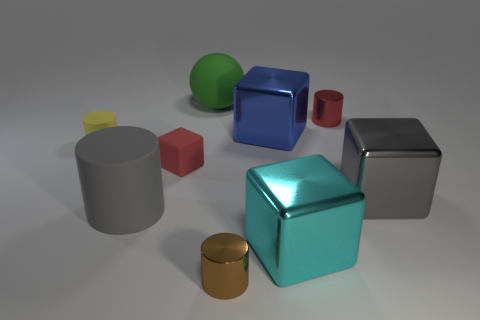Add 1 big cyan matte cylinders. How many objects exist? 10 Subtract all spheres. How many objects are left? 8 Subtract 1 cyan cubes. How many objects are left? 8 Subtract all green rubber objects. Subtract all green matte objects. How many objects are left? 7 Add 1 large gray metallic blocks. How many large gray metallic blocks are left? 2 Add 8 tiny yellow cubes. How many tiny yellow cubes exist? 8 